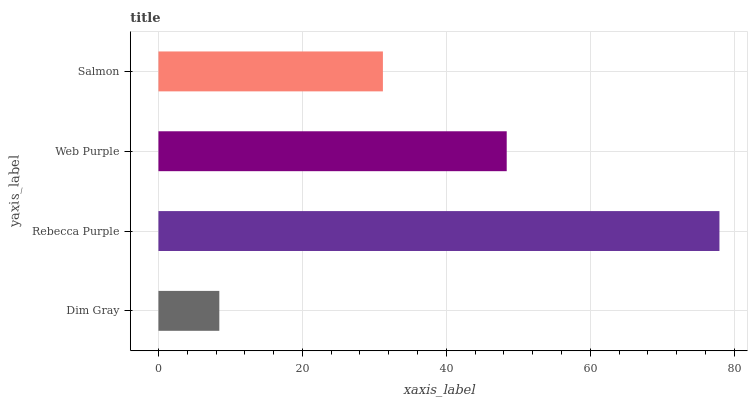Is Dim Gray the minimum?
Answer yes or no. Yes. Is Rebecca Purple the maximum?
Answer yes or no. Yes. Is Web Purple the minimum?
Answer yes or no. No. Is Web Purple the maximum?
Answer yes or no. No. Is Rebecca Purple greater than Web Purple?
Answer yes or no. Yes. Is Web Purple less than Rebecca Purple?
Answer yes or no. Yes. Is Web Purple greater than Rebecca Purple?
Answer yes or no. No. Is Rebecca Purple less than Web Purple?
Answer yes or no. No. Is Web Purple the high median?
Answer yes or no. Yes. Is Salmon the low median?
Answer yes or no. Yes. Is Dim Gray the high median?
Answer yes or no. No. Is Web Purple the low median?
Answer yes or no. No. 